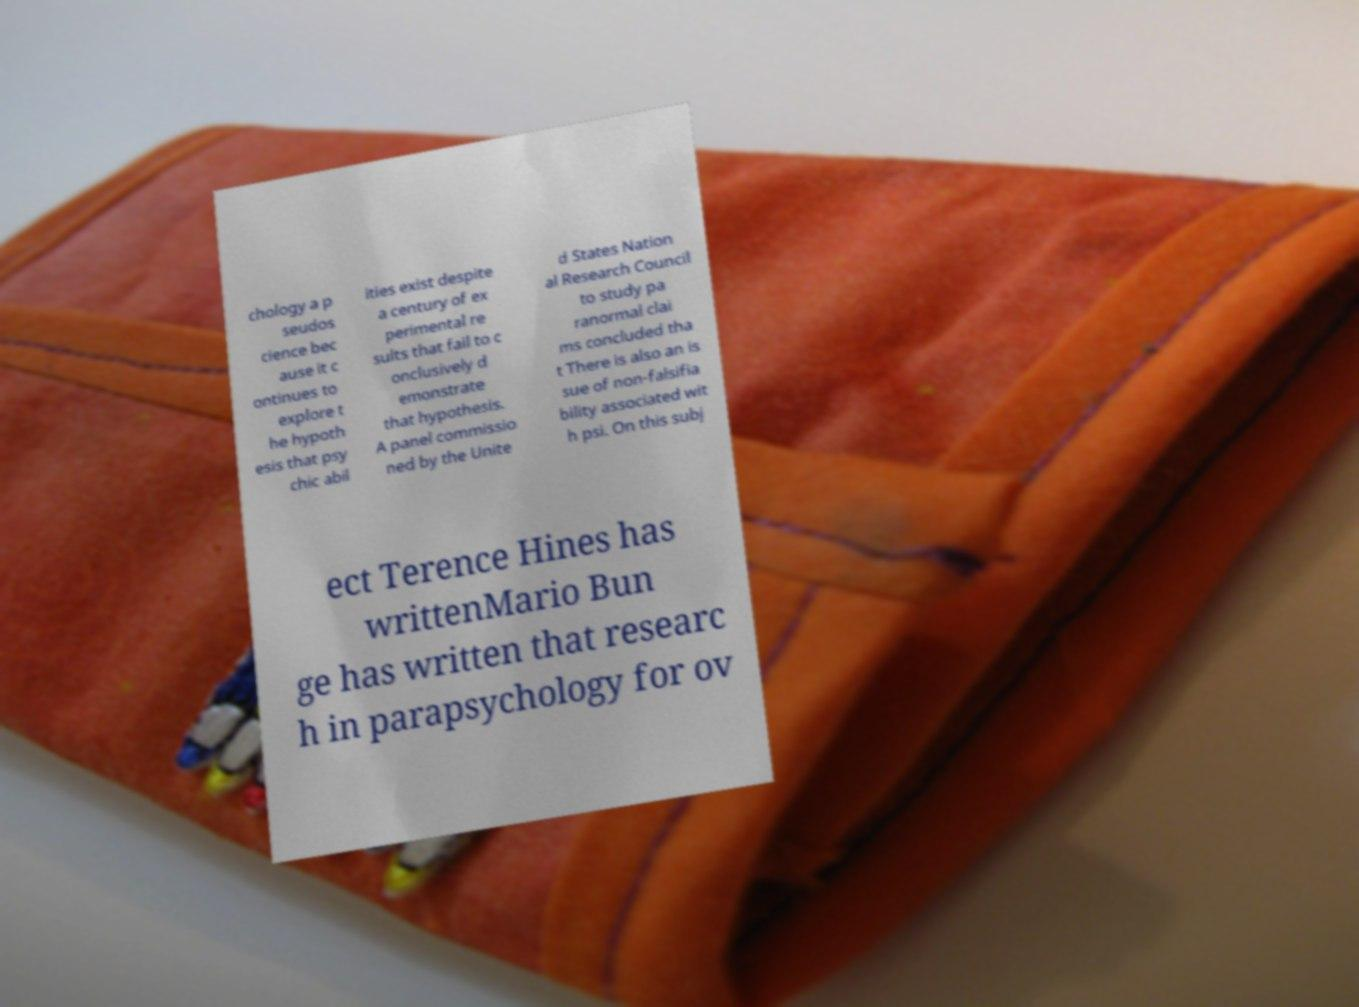What messages or text are displayed in this image? I need them in a readable, typed format. chology a p seudos cience bec ause it c ontinues to explore t he hypoth esis that psy chic abil ities exist despite a century of ex perimental re sults that fail to c onclusively d emonstrate that hypothesis. A panel commissio ned by the Unite d States Nation al Research Council to study pa ranormal clai ms concluded tha t There is also an is sue of non-falsifia bility associated wit h psi. On this subj ect Terence Hines has writtenMario Bun ge has written that researc h in parapsychology for ov 